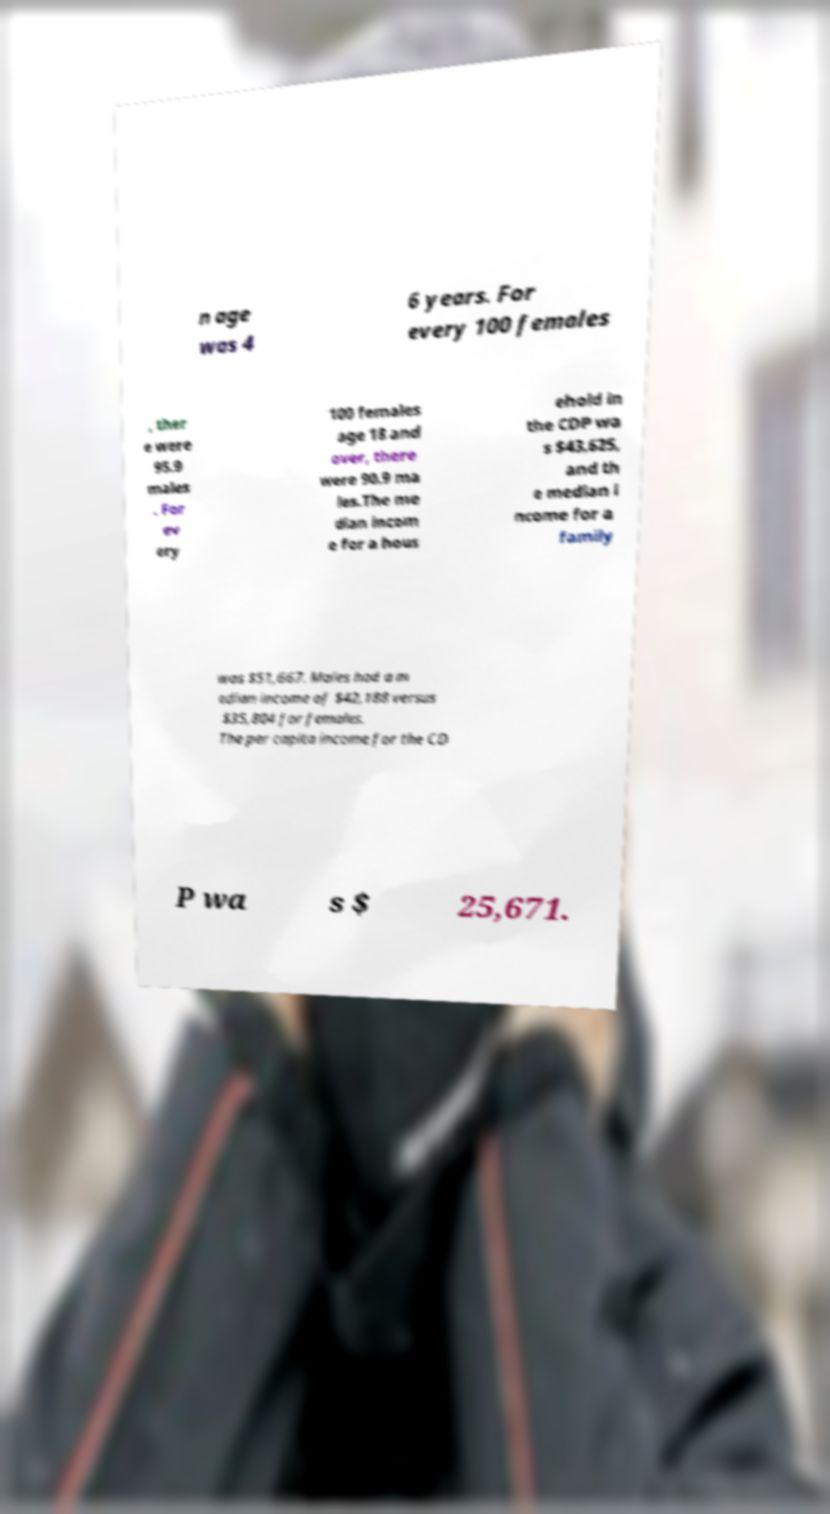What messages or text are displayed in this image? I need them in a readable, typed format. n age was 4 6 years. For every 100 females , ther e were 95.9 males . For ev ery 100 females age 18 and over, there were 90.9 ma les.The me dian incom e for a hous ehold in the CDP wa s $43,625, and th e median i ncome for a family was $51,667. Males had a m edian income of $42,188 versus $35,804 for females. The per capita income for the CD P wa s $ 25,671. 